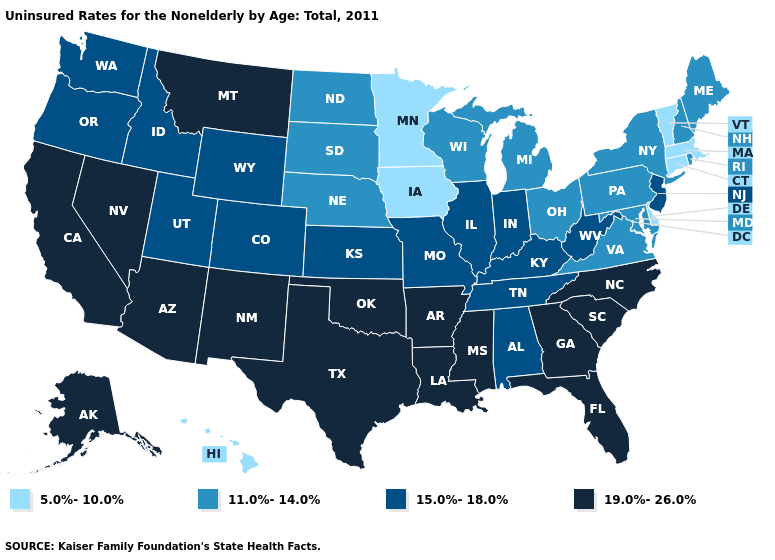What is the value of Michigan?
Concise answer only. 11.0%-14.0%. What is the value of New Hampshire?
Keep it brief. 11.0%-14.0%. Among the states that border Vermont , does Massachusetts have the lowest value?
Keep it brief. Yes. Which states hav the highest value in the MidWest?
Quick response, please. Illinois, Indiana, Kansas, Missouri. Does Iowa have a higher value than Maine?
Be succinct. No. What is the lowest value in the USA?
Short answer required. 5.0%-10.0%. What is the highest value in states that border New Hampshire?
Write a very short answer. 11.0%-14.0%. Does Alaska have a higher value than Mississippi?
Keep it brief. No. What is the highest value in the USA?
Quick response, please. 19.0%-26.0%. Is the legend a continuous bar?
Keep it brief. No. Name the states that have a value in the range 19.0%-26.0%?
Keep it brief. Alaska, Arizona, Arkansas, California, Florida, Georgia, Louisiana, Mississippi, Montana, Nevada, New Mexico, North Carolina, Oklahoma, South Carolina, Texas. Name the states that have a value in the range 5.0%-10.0%?
Answer briefly. Connecticut, Delaware, Hawaii, Iowa, Massachusetts, Minnesota, Vermont. Which states have the lowest value in the USA?
Quick response, please. Connecticut, Delaware, Hawaii, Iowa, Massachusetts, Minnesota, Vermont. What is the lowest value in states that border Utah?
Give a very brief answer. 15.0%-18.0%. Among the states that border North Dakota , does Minnesota have the lowest value?
Give a very brief answer. Yes. 